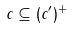<formula> <loc_0><loc_0><loc_500><loc_500>c \subseteq ( c ^ { \prime } ) ^ { + }</formula> 